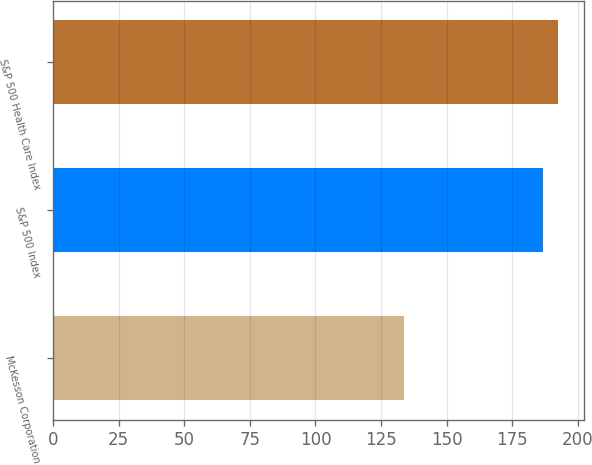Convert chart. <chart><loc_0><loc_0><loc_500><loc_500><bar_chart><fcel>McKesson Corporation<fcel>S&P 500 Index<fcel>S&P 500 Health Care Index<nl><fcel>133.64<fcel>186.75<fcel>192.59<nl></chart> 